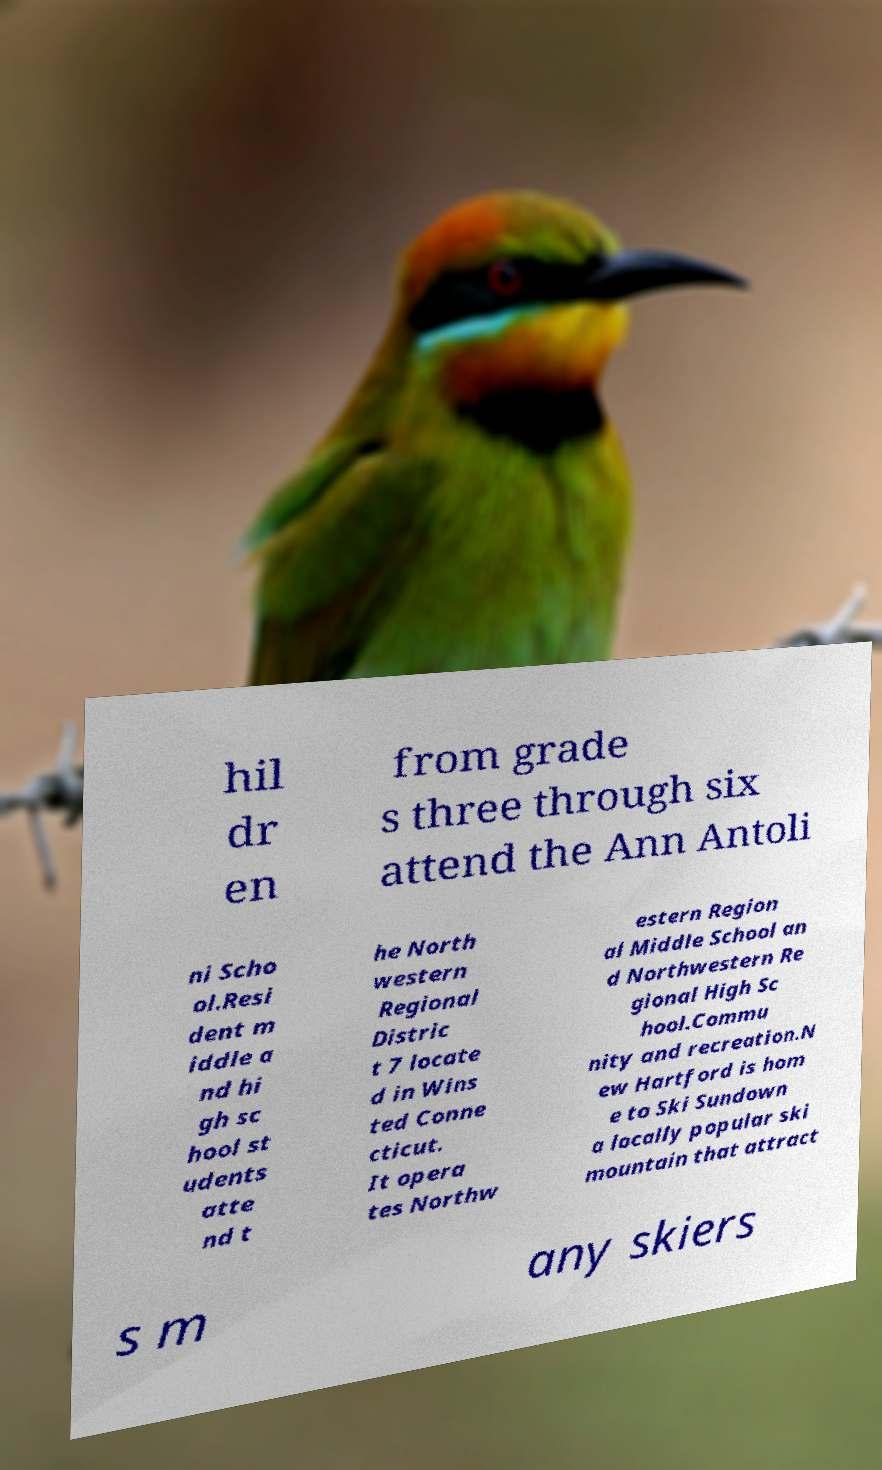Can you accurately transcribe the text from the provided image for me? hil dr en from grade s three through six attend the Ann Antoli ni Scho ol.Resi dent m iddle a nd hi gh sc hool st udents atte nd t he North western Regional Distric t 7 locate d in Wins ted Conne cticut. It opera tes Northw estern Region al Middle School an d Northwestern Re gional High Sc hool.Commu nity and recreation.N ew Hartford is hom e to Ski Sundown a locally popular ski mountain that attract s m any skiers 